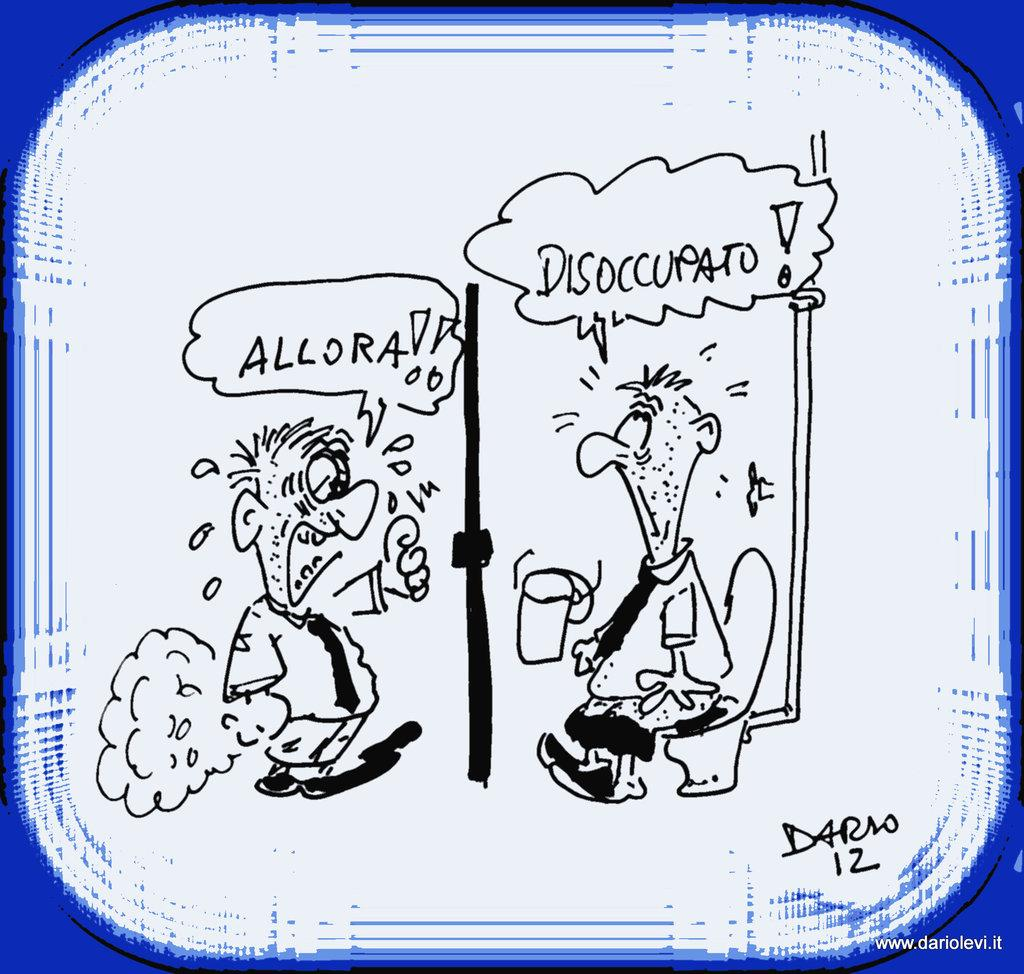What is depicted in the drawing in the image? There is there a drawing of two persons in the image. Besides the drawing, what other elements can be seen in the image? There are words and numbers in the image. Is there any indication of the image's origin or ownership? Yes, there is a watermark on the image. What type of sidewalk can be seen in the image? There is no sidewalk present in the image. Can you describe the sun's position in the image? There is no sun present in the image. 